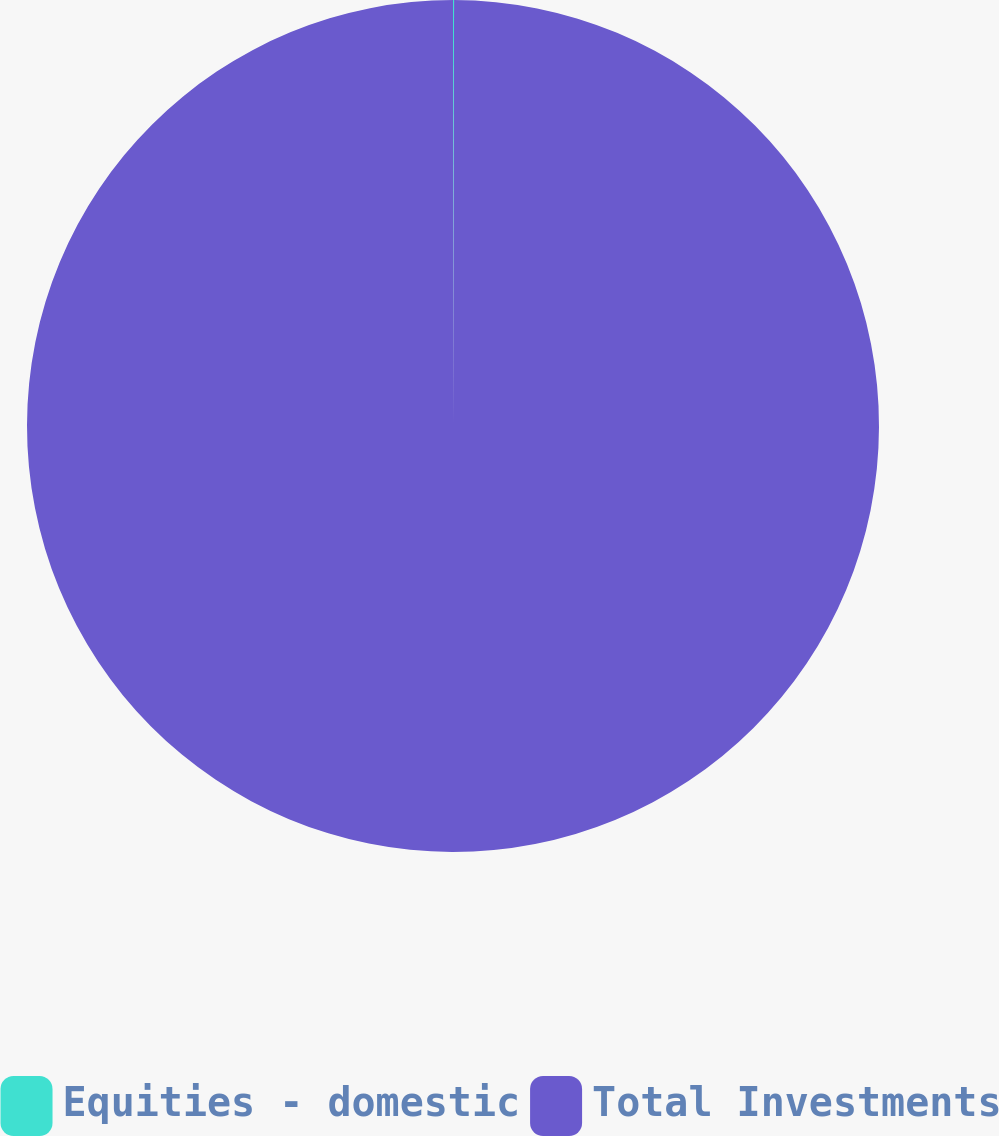Convert chart to OTSL. <chart><loc_0><loc_0><loc_500><loc_500><pie_chart><fcel>Equities - domestic<fcel>Total Investments<nl><fcel>0.04%<fcel>99.96%<nl></chart> 